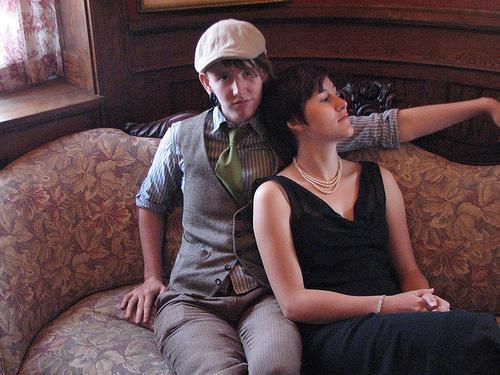How many people are there?
Give a very brief answer. 2. 